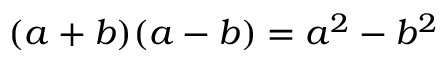Convert formula to latex. <formula><loc_0><loc_0><loc_500><loc_500>( a + b ) ( a - b ) = a ^ { 2 } - b ^ { 2 }</formula> 